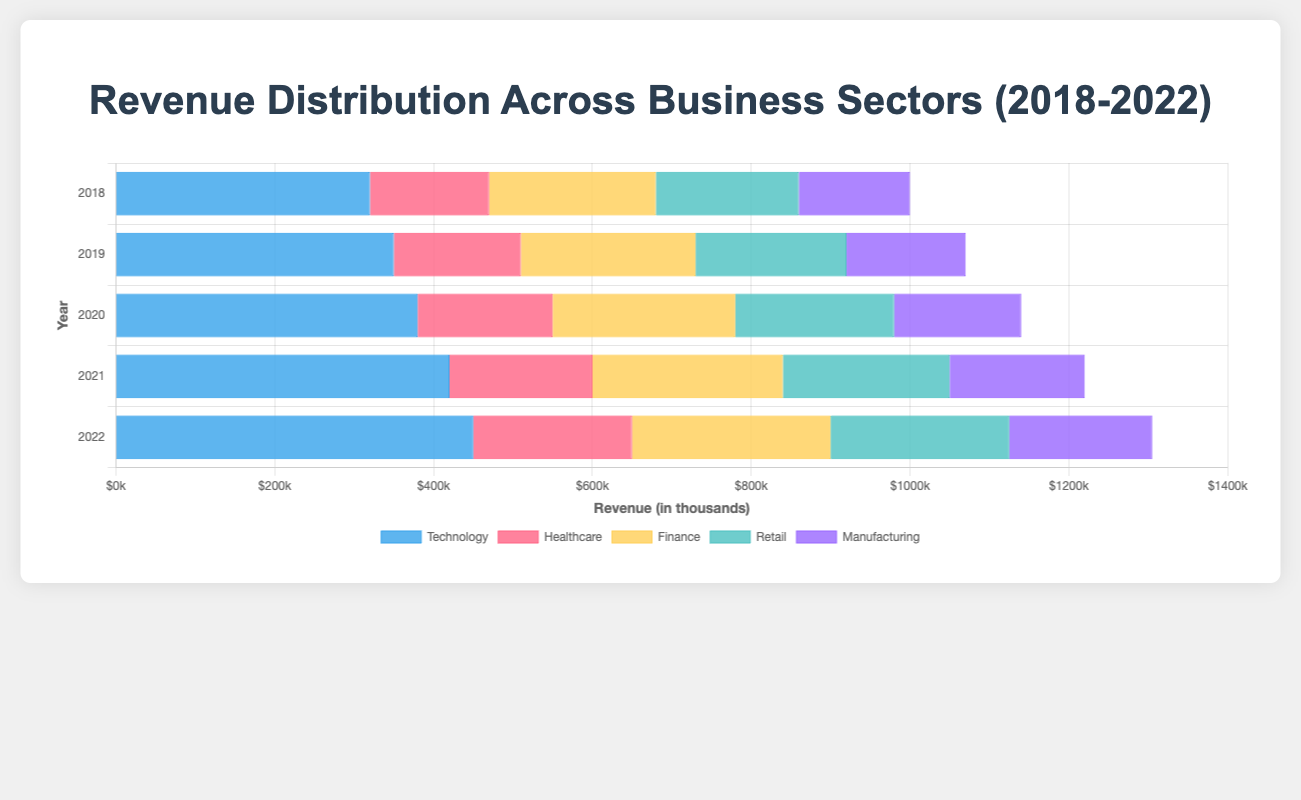1. What is the total revenue for the Technology sector over the past five years? To find the total revenue for the Technology sector from 2018 to 2022, add the revenues for each year: 320,000 (2018) + 350,000 (2019) + 380,000 (2020) + 420,000 (2021) + 450,000 (2022) = 1,920,000
Answer: 1,920,000 2. Which sector had the highest revenue in 2021? To determine which sector had the highest revenue in 2021, compare the revenues of all sectors for that year. The revenues are: Technology (420,000), Healthcare (180,000), Finance (240,000), Retail (210,000), Manufacturing (170,000). The highest revenue is in the Technology sector with 420,000
Answer: Technology 3. How much more revenue did the Retail sector generate in 2022 compared to 2018? To find the difference in revenue generated by the Retail sector between 2022 and 2018, subtract the 2018 revenue from the 2022 revenue: 225,000 (2022) - 180,000 (2018) = 45,000
Answer: 45,000 4. What is the average annual revenue for the Healthcare sector over the five years? To find the average revenue for the Healthcare sector, add the revenues from 2018 to 2022 and divide by 5: (150,000 + 160,000 + 170,000 + 180,000 + 200,000) / 5 = 860,000 / 5 = 172,000
Answer: 172,000 5. Which sector saw the largest increase in revenue from 2018 to 2022? To find the sector with the largest increase, calculate the difference in revenue for each sector between 2018 and 2022. Then compare: Technology (450,000 - 320,000 = 130,000), Healthcare (200,000 - 150,000 = 50,000), Finance (250,000 - 210,000 = 40,000), Retail (225,000 - 180,000 = 45,000), Manufacturing (180,000 - 140,000 = 40,000). The largest increase is in Technology with 130,000
Answer: Technology 6. Compare the revenue contribution of the Manufacturing sector in 2021 with that in 2019. Has it increased or decreased? To compare the revenues, look at the Manufacturing sector in 2019 (150,000) and 2021 (170,000). The revenue has increased by 20,000 from 2019 to 2021
Answer: Increased 7. What is the combined revenue for the Finance and Retail sectors in 2020? To find the combined revenue for Finance and Retail in 2020, add their revenues: 230,000 (Finance) + 200,000 (Retail) = 430,000
Answer: 430,000 8. Which year had the lowest total revenue across all sectors combined? To find the year with the lowest total revenue, add the revenues of all sectors for each year and compare. 2018: 1,000,000, 2019: 1,070,000, 2020: 1,140,000, 2021: 1,220,000, 2022: 1,305,000. The lowest total revenue is in 2018
Answer: 2018 9. By how much did the Healthcare sector's revenue increase between 2021 and 2022? To find the increase, subtract the 2021 revenue from the 2022 revenue: 200,000 (2022) - 180,000 (2021) = 20,000
Answer: 20,000 10. During which year did Technology contribute more than half of the total revenue across all sectors? First, calculate the total revenue for each year and find half of it. Then check if Technology's revenue for that year exceeds this value. Total in 2018: 1,000,000, half: 500,000; 2019: 1,070,000, half: 535,000; 2020: 1,140,000, half: 570,000; 2021: 1,220,000, half: 610,000; 2022: 1,305,000, half: 652,500. Technology never exceeds these values
Answer: None 